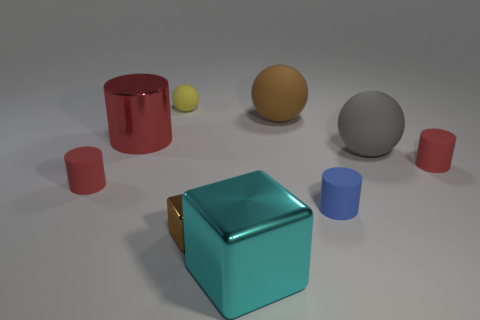Is there a gray ball of the same size as the brown metal object? After examining the image, it appears that there is no gray ball present that matches the size of the brown metal object, which seems to be a cube. Instead, there is a smaller gray ball in the scene. 